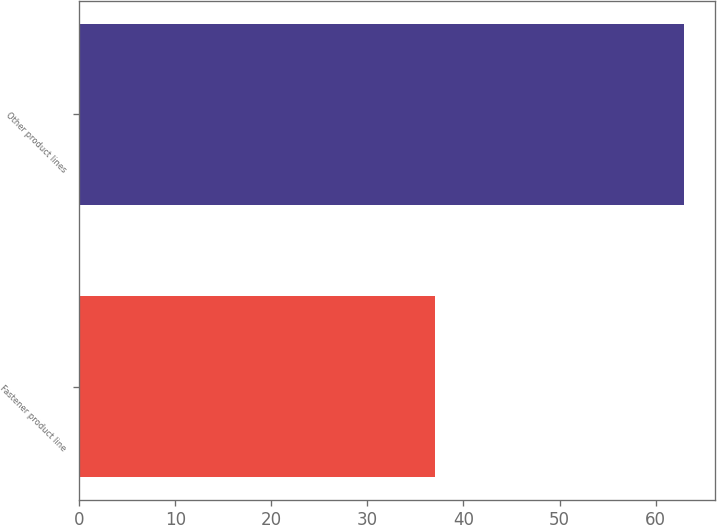<chart> <loc_0><loc_0><loc_500><loc_500><bar_chart><fcel>Fastener product line<fcel>Other product lines<nl><fcel>37<fcel>63<nl></chart> 